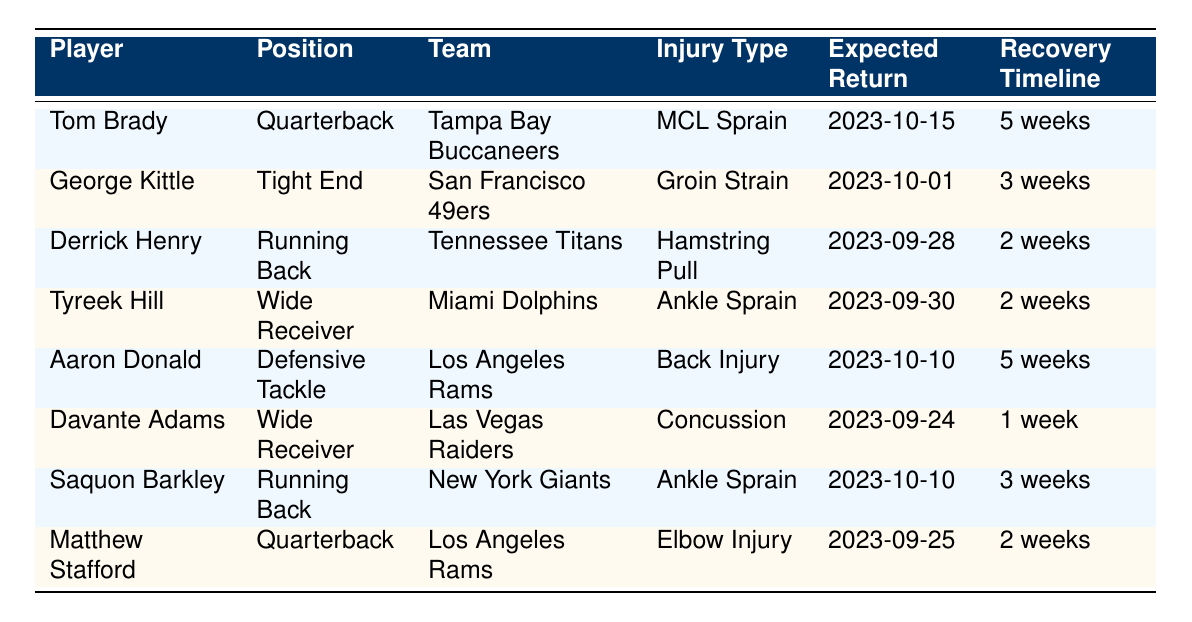What injury does Tom Brady have? Tom Brady's injury is listed in the table under the "Injury Type" column. It shows that he has an MCL Sprain.
Answer: MCL Sprain When is Derrick Henry expected to return? By looking at the "Expected Return" column for Derrick Henry, it states that he is expected to return on September 28, 2023.
Answer: 2023-09-28 How many players are expected to return in October? To find this, we need to check the "Expected Return" dates. Two players, Tom Brady (October 15) and Saquon Barkley (October 10), are expected to return in October. Therefore, the total is 2 players.
Answer: 2 Is Saquon Barkley’s injury type a concussion? By examining the "Injury Type" column for Saquon Barkley, his injury is listed as an Ankle Sprain, not a concussion. Thus, the answer is false.
Answer: No Which quarterback has the longest recovery timeline? We compare the "Recovery Timeline" for each quarterback listed. Tom Brady's recovery timeline is 5 weeks, while Matthew Stafford's is 2 weeks. Hence, Tom Brady has the longest recovery timeline among the quarterbacks.
Answer: Tom Brady What is the average recovery timeline for all injured players listed? We first convert the recovery timelines into weeks: 5, 3, 2, 2, 5, 1, 3, and 2 weeks respectively. Adding these gives 5 + 3 + 2 + 2 + 5 + 1 + 3 + 2 = 23 weeks. There are 8 players, so we calculate the average as 23 / 8 = 2.875 weeks.
Answer: 2.875 weeks Does any player have a 1-week recovery timeline? By checking the "Recovery Timeline" column, Davante Adams is listed with a 1-week recovery timeline. Thus, the statement is true.
Answer: Yes Which team's player is expected to return the latest? We look through the "Expected Return" dates for each player and find that Tom Brady is expected to return the latest on October 15, 2023.
Answer: Tampa Bay Buccaneers 